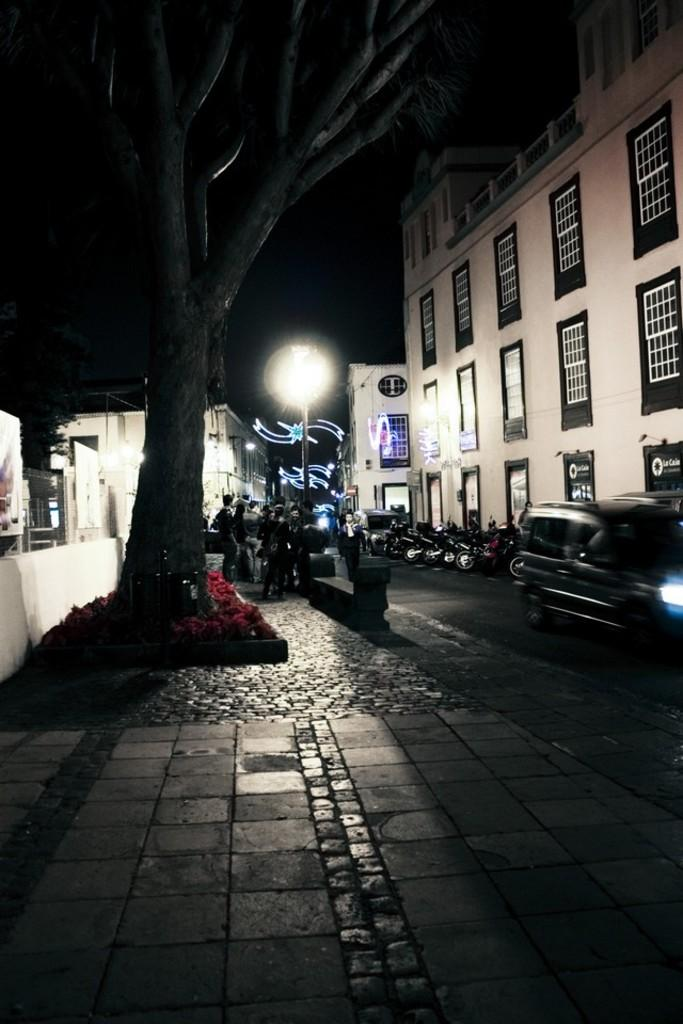What type of structure is visible in the image? There is a building in the image. What color is the building? The building is white. What else can be seen on the road in the image? There are vehicles on the road in the image. What other objects are present in the image? There is a light pole and trees in the image. What is the color of the background in the image? The background of the image is black. How many women are playing on the playground in the image? There is no playground or women present in the image. What type of rainstorm can be seen in the image? There is no rainstorm visible in the image. 